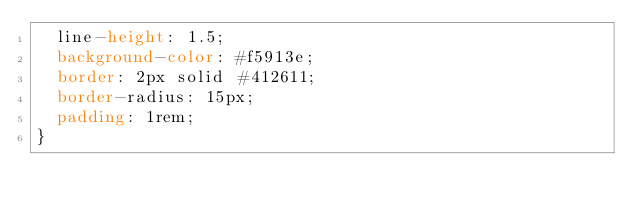<code> <loc_0><loc_0><loc_500><loc_500><_CSS_>  line-height: 1.5;
  background-color: #f5913e;
  border: 2px solid #412611;
  border-radius: 15px;
  padding: 1rem;
}
</code> 